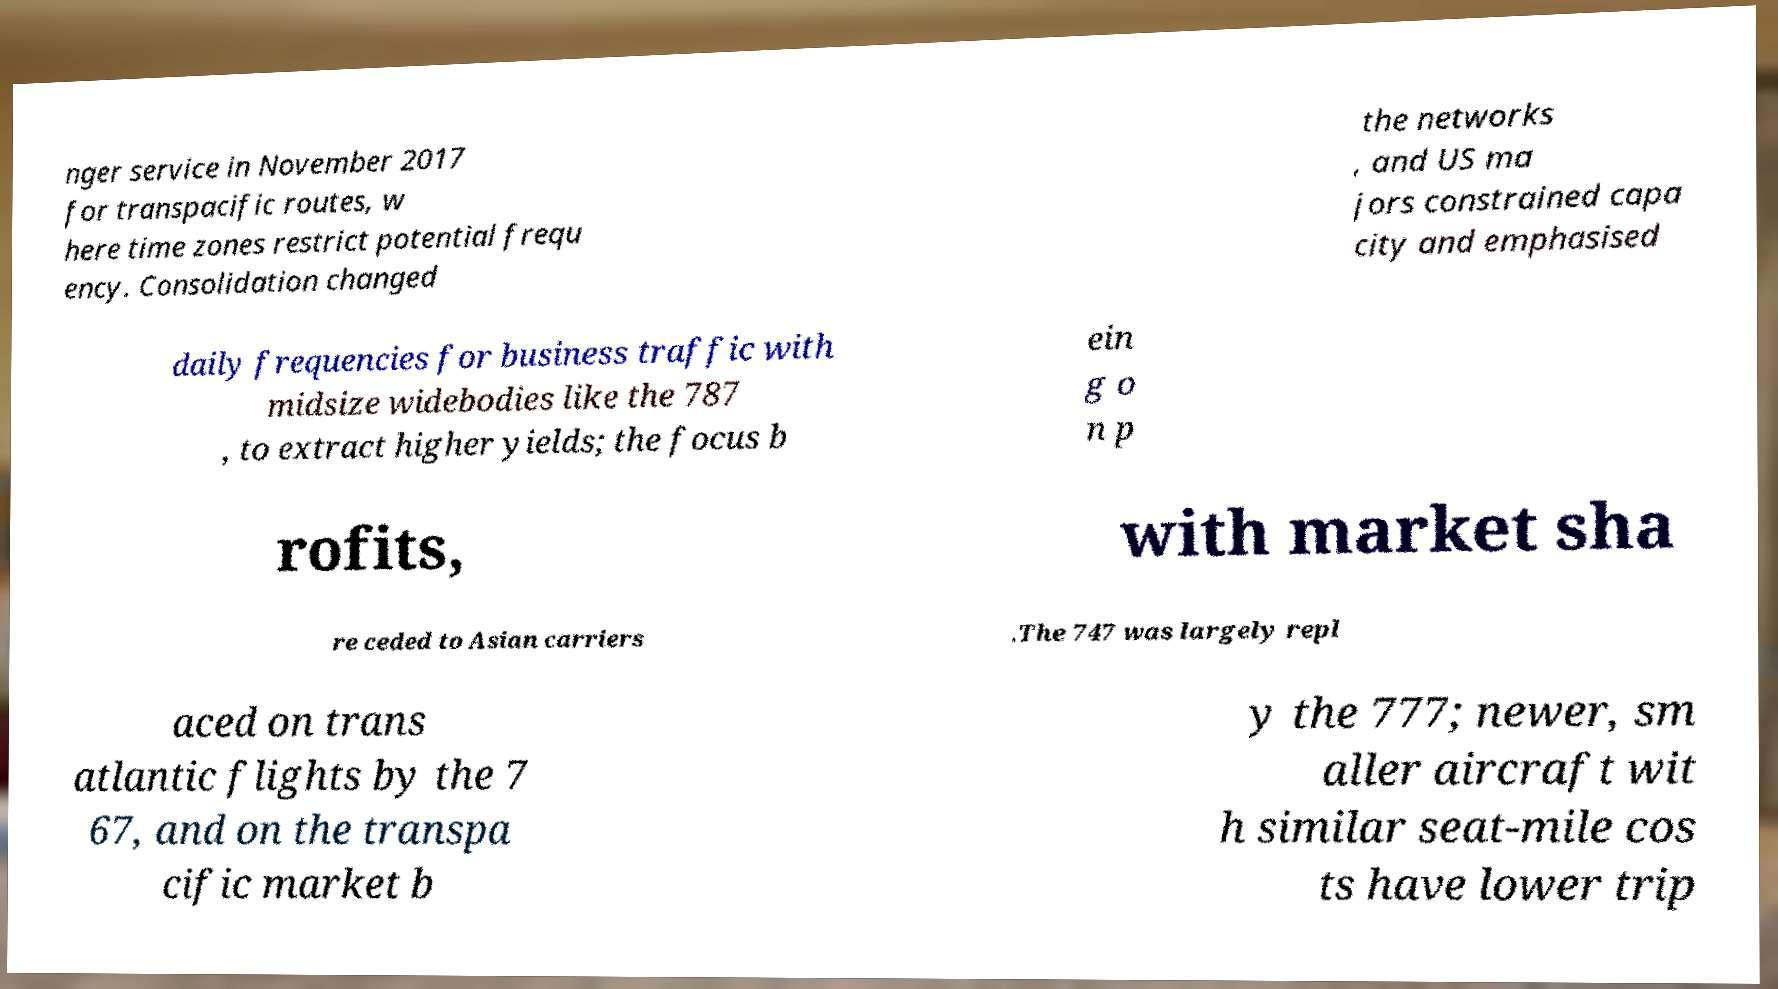There's text embedded in this image that I need extracted. Can you transcribe it verbatim? nger service in November 2017 for transpacific routes, w here time zones restrict potential frequ ency. Consolidation changed the networks , and US ma jors constrained capa city and emphasised daily frequencies for business traffic with midsize widebodies like the 787 , to extract higher yields; the focus b ein g o n p rofits, with market sha re ceded to Asian carriers .The 747 was largely repl aced on trans atlantic flights by the 7 67, and on the transpa cific market b y the 777; newer, sm aller aircraft wit h similar seat-mile cos ts have lower trip 